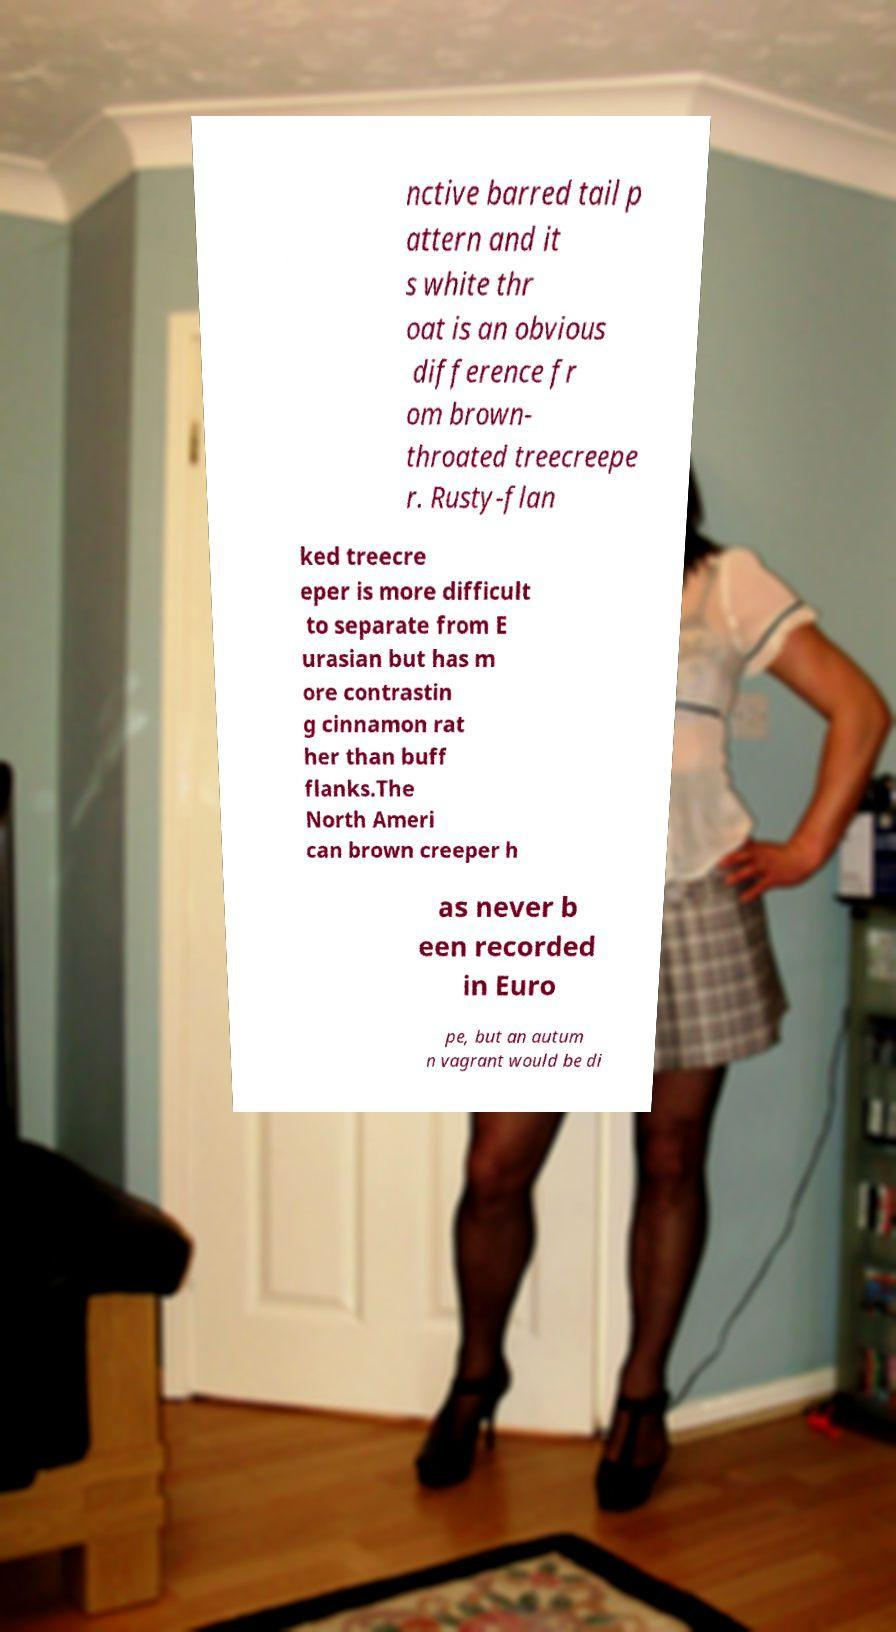I need the written content from this picture converted into text. Can you do that? nctive barred tail p attern and it s white thr oat is an obvious difference fr om brown- throated treecreepe r. Rusty-flan ked treecre eper is more difficult to separate from E urasian but has m ore contrastin g cinnamon rat her than buff flanks.The North Ameri can brown creeper h as never b een recorded in Euro pe, but an autum n vagrant would be di 